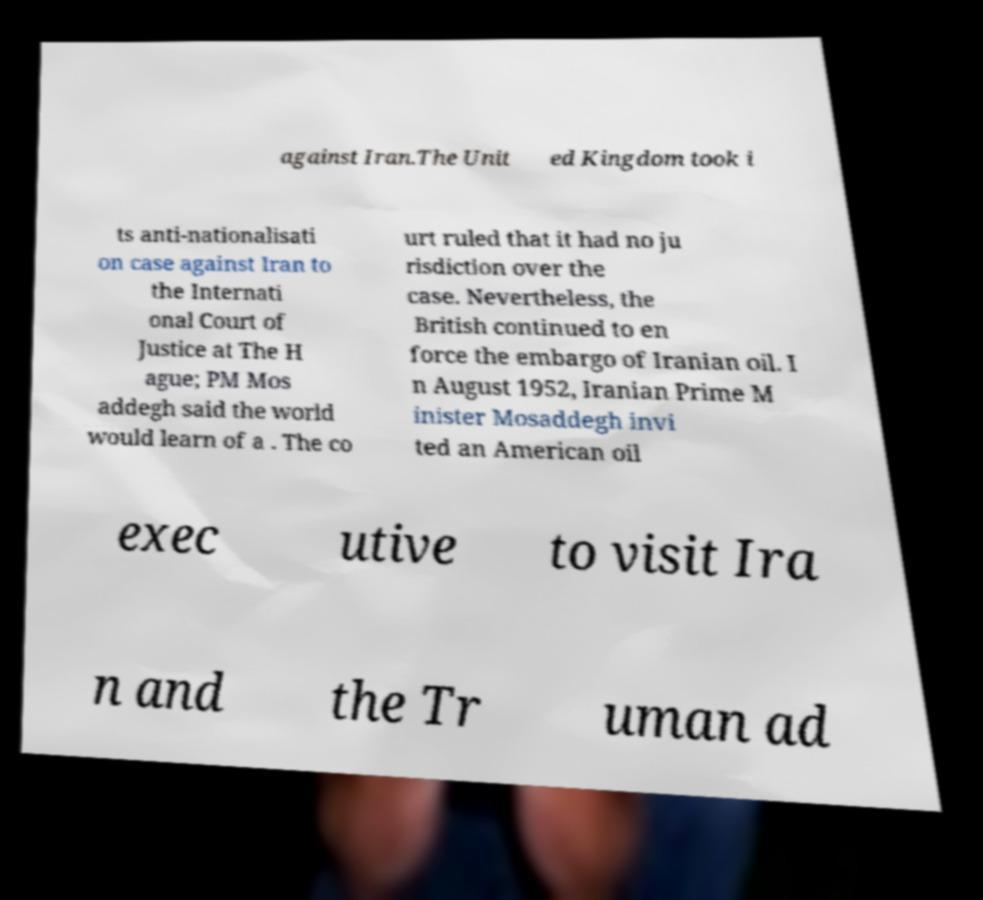Could you assist in decoding the text presented in this image and type it out clearly? against Iran.The Unit ed Kingdom took i ts anti-nationalisati on case against Iran to the Internati onal Court of Justice at The H ague; PM Mos addegh said the world would learn of a . The co urt ruled that it had no ju risdiction over the case. Nevertheless, the British continued to en force the embargo of Iranian oil. I n August 1952, Iranian Prime M inister Mosaddegh invi ted an American oil exec utive to visit Ira n and the Tr uman ad 